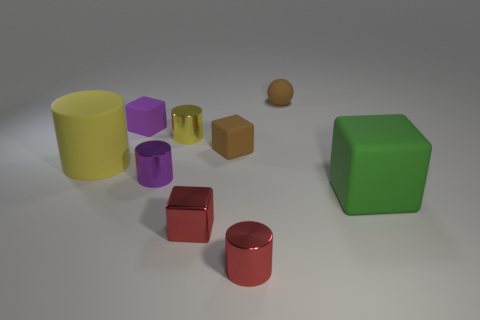The large thing on the left side of the large object that is to the right of the tiny shiny block is made of what material?
Make the answer very short. Rubber. There is a matte object in front of the large yellow cylinder; what is its size?
Your answer should be very brief. Large. The tiny matte object that is both on the right side of the tiny red cube and in front of the small brown rubber sphere is what color?
Provide a short and direct response. Brown. There is a purple thing behind the yellow matte thing; is its size the same as the big yellow rubber object?
Ensure brevity in your answer.  No. There is a brown rubber ball that is behind the tiny red metallic cylinder; are there any rubber cylinders that are to the left of it?
Keep it short and to the point. Yes. What is the material of the tiny purple cube?
Make the answer very short. Rubber. Are there any tiny metal cubes in front of the big cylinder?
Offer a terse response. Yes. The yellow matte object that is the same shape as the yellow metal object is what size?
Your response must be concise. Large. Are there the same number of objects behind the small red block and objects that are in front of the tiny purple matte thing?
Provide a short and direct response. Yes. How many brown cubes are there?
Make the answer very short. 1. 